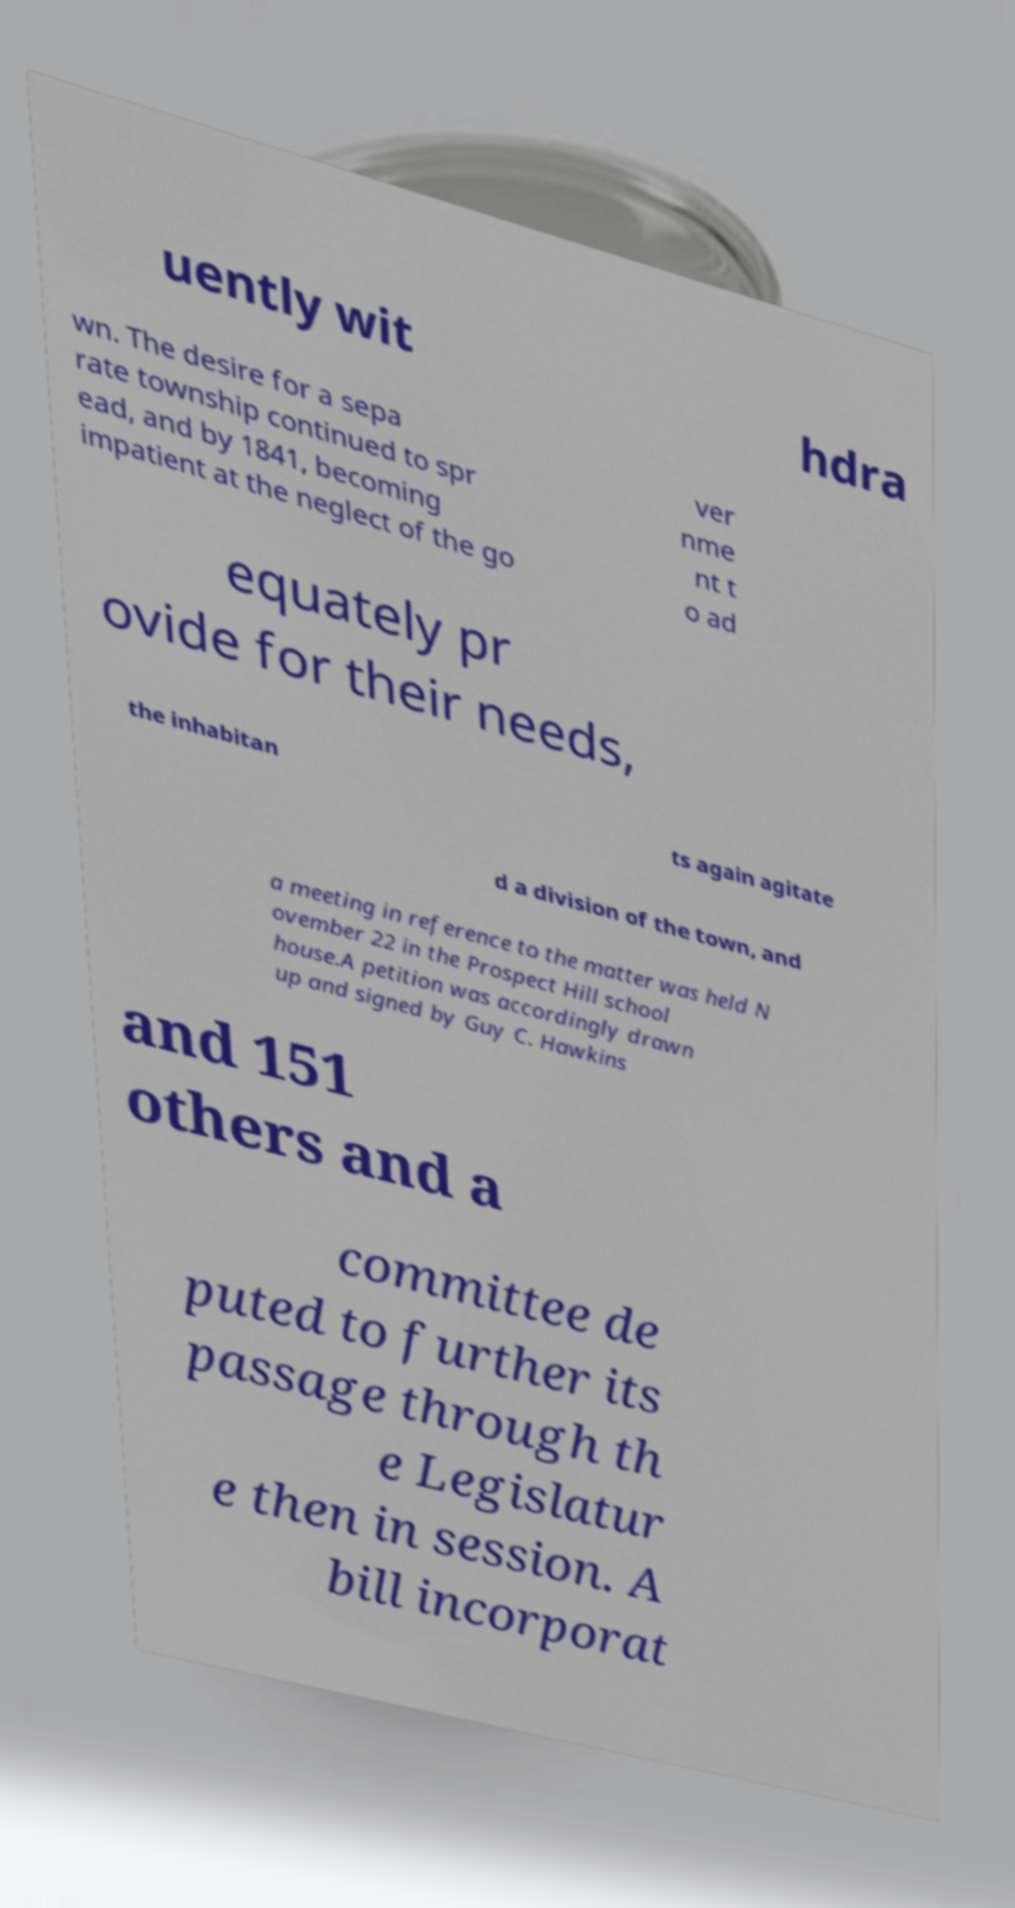Can you accurately transcribe the text from the provided image for me? uently wit hdra wn. The desire for a sepa rate township continued to spr ead, and by 1841, becoming impatient at the neglect of the go ver nme nt t o ad equately pr ovide for their needs, the inhabitan ts again agitate d a division of the town, and a meeting in reference to the matter was held N ovember 22 in the Prospect Hill school house.A petition was accordingly drawn up and signed by Guy C. Hawkins and 151 others and a committee de puted to further its passage through th e Legislatur e then in session. A bill incorporat 